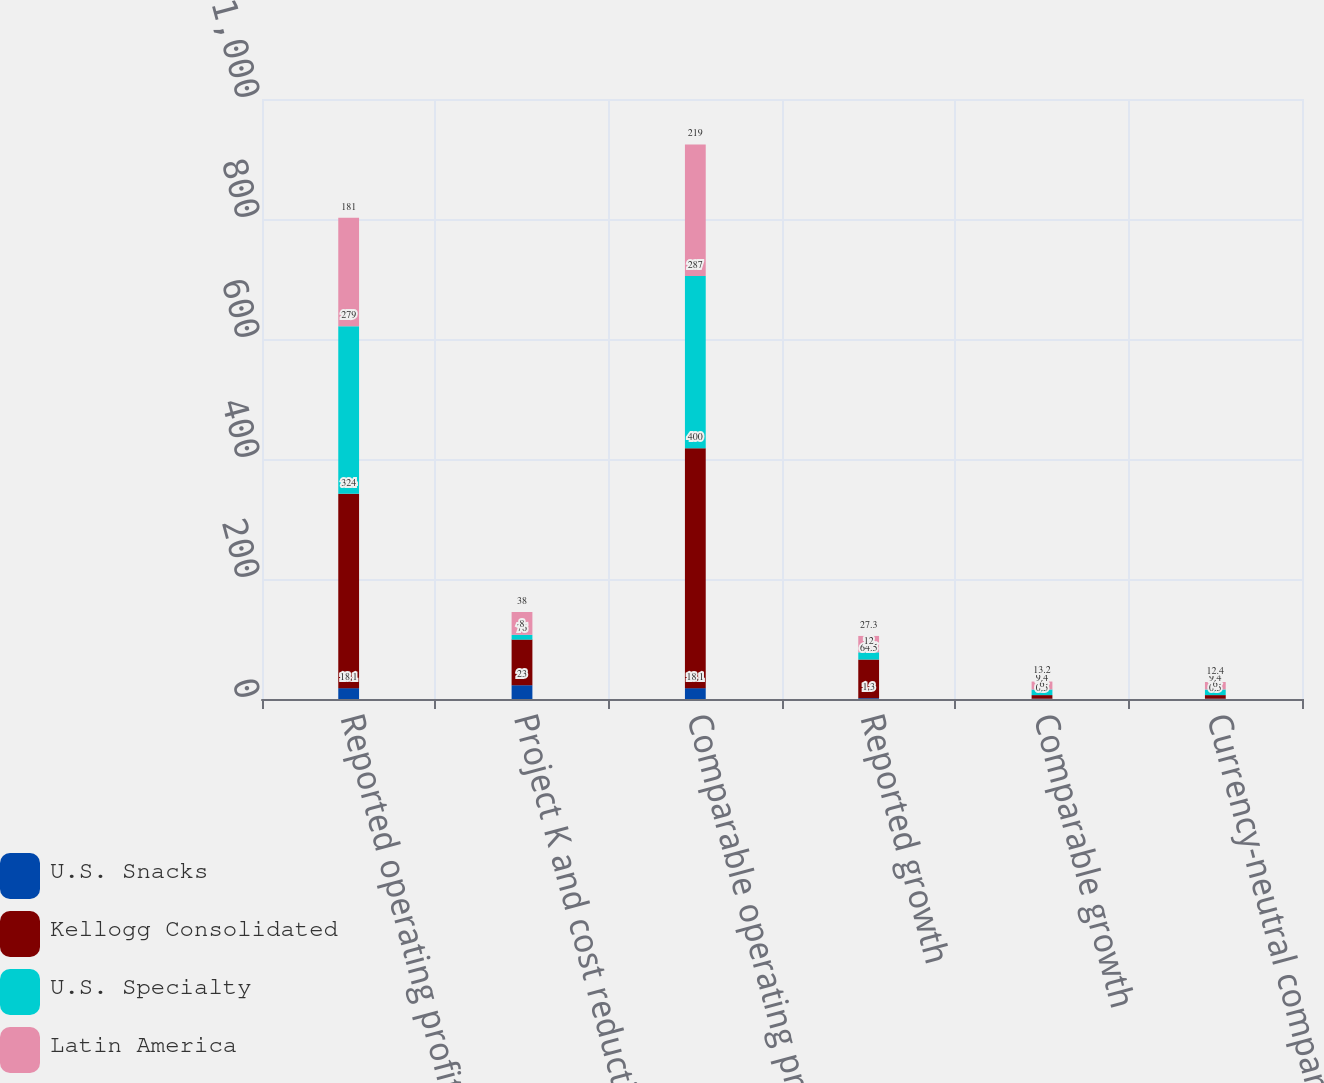Convert chart. <chart><loc_0><loc_0><loc_500><loc_500><stacked_bar_chart><ecel><fcel>Reported operating profit<fcel>Project K and cost reduction<fcel>Comparable operating profit<fcel>Reported growth<fcel>Comparable growth<fcel>Currency-neutral comparable<nl><fcel>U.S. Snacks<fcel>18.1<fcel>23<fcel>18.1<fcel>1.3<fcel>0.5<fcel>0.5<nl><fcel>Kellogg Consolidated<fcel>324<fcel>76<fcel>400<fcel>64.5<fcel>6<fcel>6<nl><fcel>U.S. Specialty<fcel>279<fcel>8<fcel>287<fcel>12<fcel>9.4<fcel>9.4<nl><fcel>Latin America<fcel>181<fcel>38<fcel>219<fcel>27.3<fcel>13.2<fcel>12.4<nl></chart> 